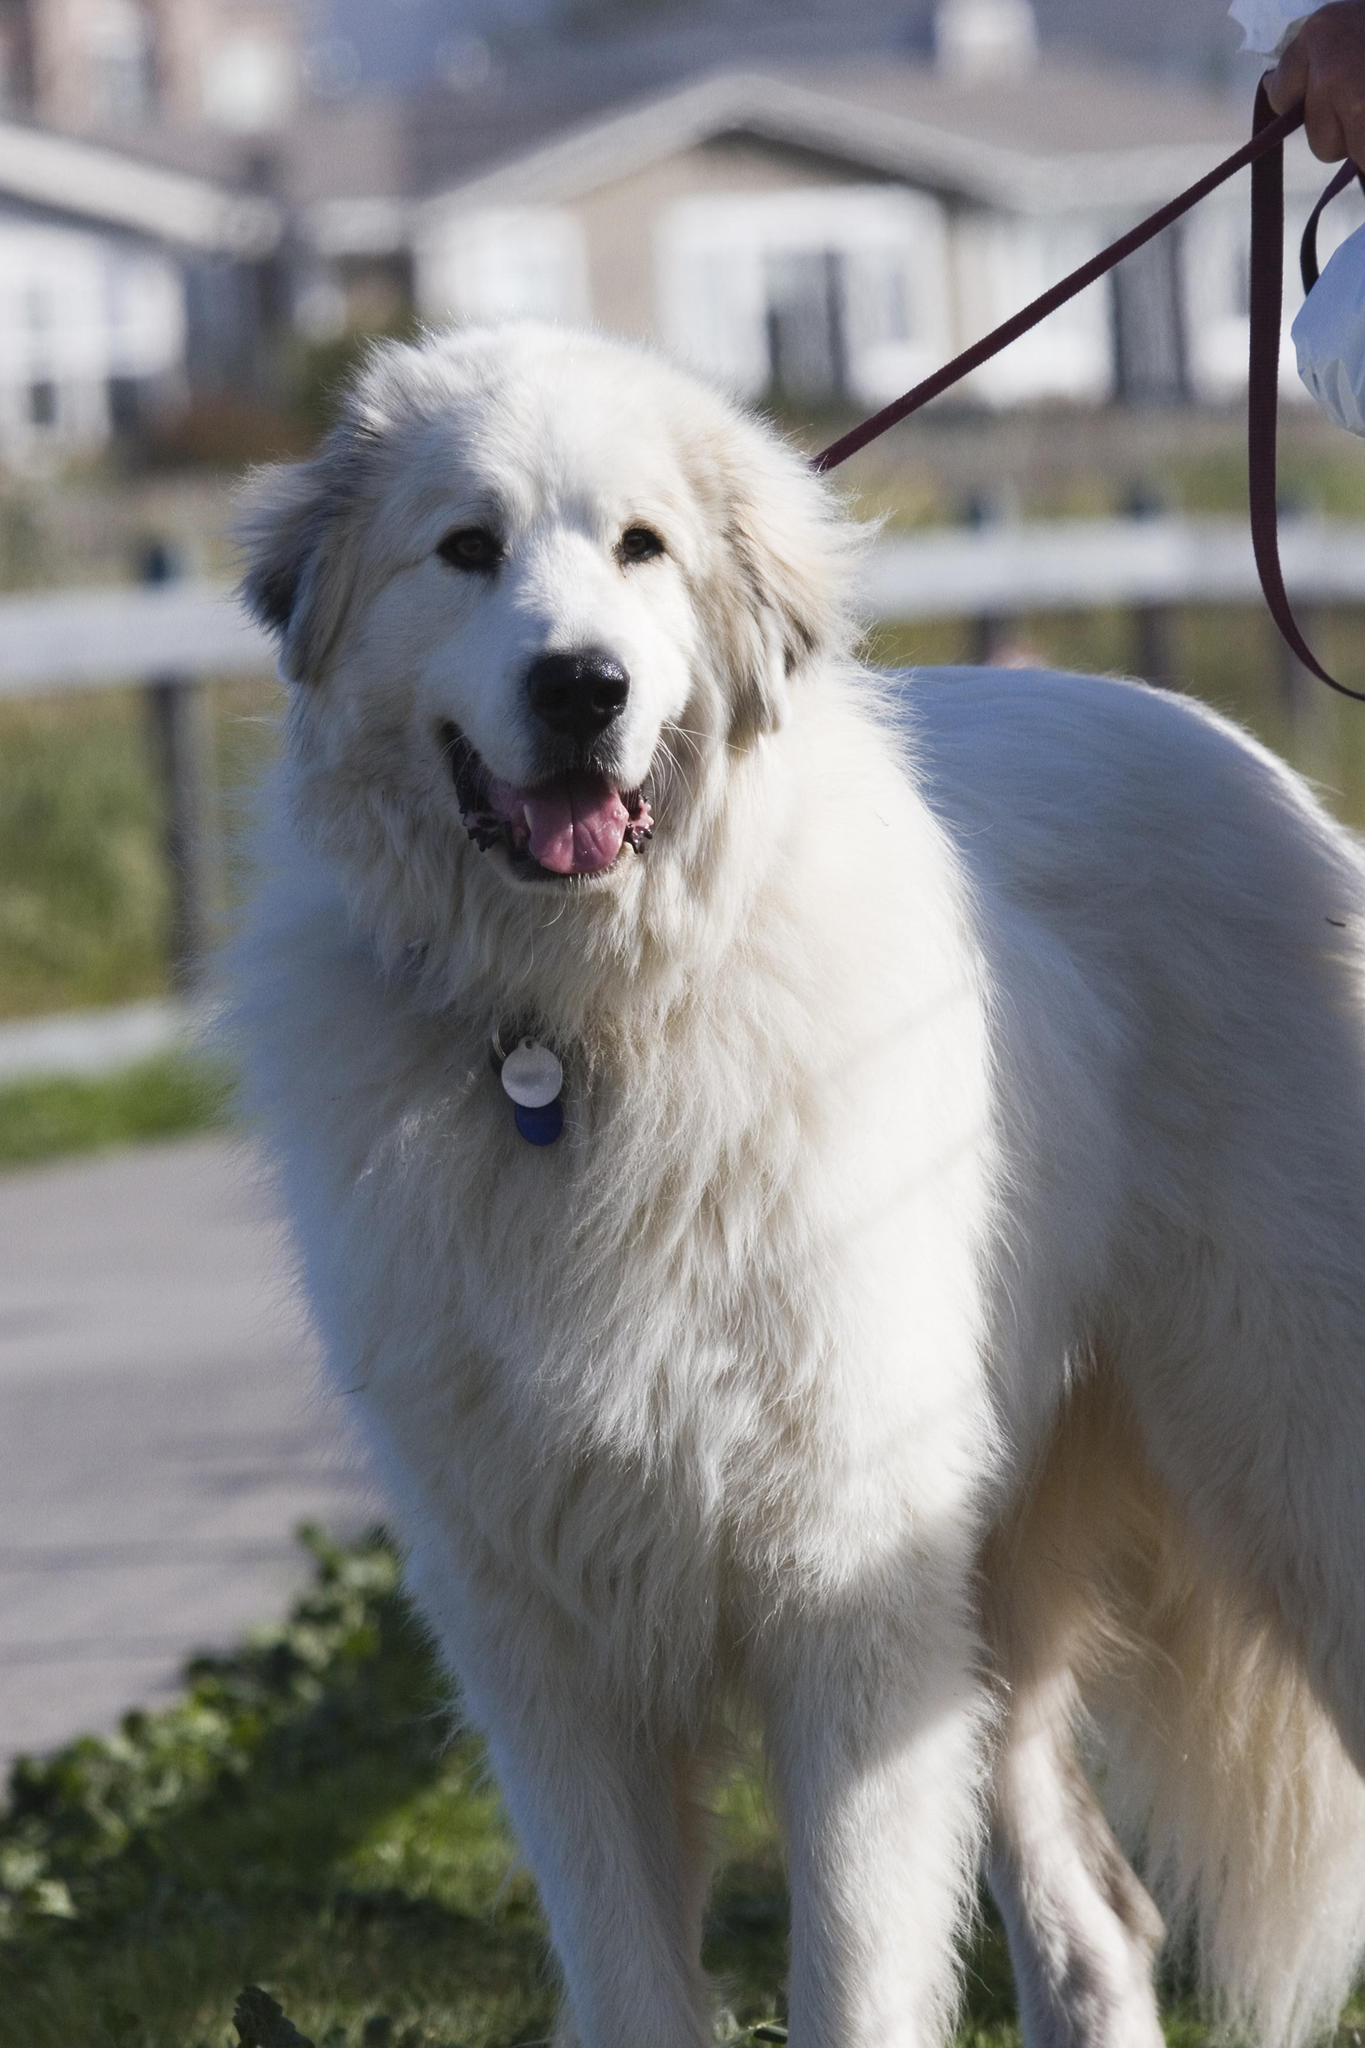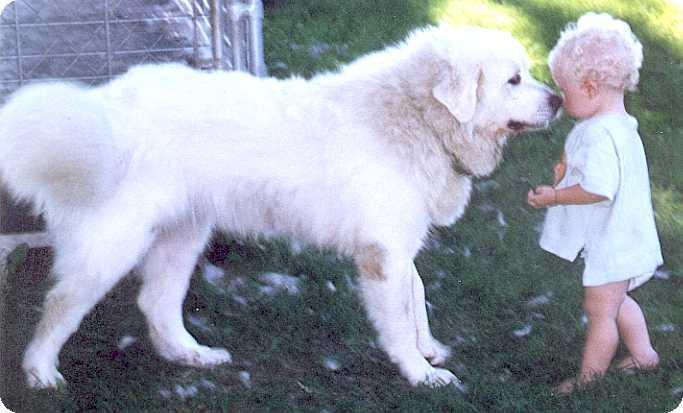The first image is the image on the left, the second image is the image on the right. For the images shown, is this caption "At least one of the dogs has a collar and tag clearly visible around it's neck." true? Answer yes or no. Yes. The first image is the image on the left, the second image is the image on the right. For the images displayed, is the sentence "The dog in the right image is facing right." factually correct? Answer yes or no. Yes. 